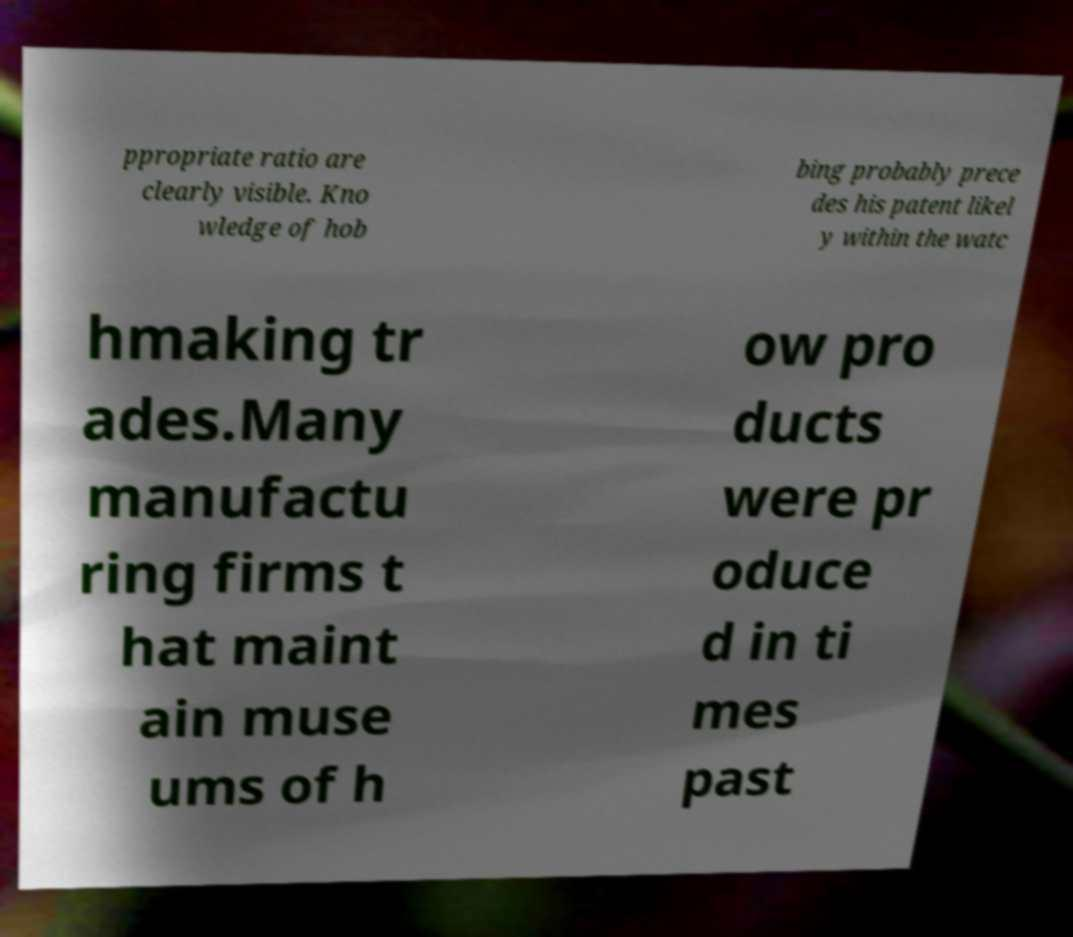What messages or text are displayed in this image? I need them in a readable, typed format. ppropriate ratio are clearly visible. Kno wledge of hob bing probably prece des his patent likel y within the watc hmaking tr ades.Many manufactu ring firms t hat maint ain muse ums of h ow pro ducts were pr oduce d in ti mes past 